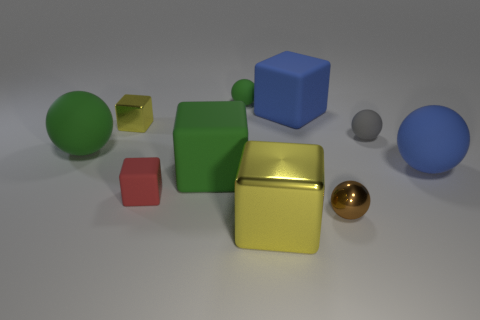How many yellow cubes have the same material as the small brown ball?
Your answer should be very brief. 2. The metallic object that is the same color as the large shiny block is what shape?
Your response must be concise. Cube. Do the small red matte thing on the left side of the brown ball and the small green object have the same shape?
Offer a very short reply. No. What is the color of the tiny cube that is the same material as the tiny green thing?
Your response must be concise. Red. There is a yellow metallic block that is behind the small sphere that is in front of the big blue matte sphere; is there a green matte sphere behind it?
Your answer should be very brief. Yes. What is the shape of the tiny brown metallic object?
Keep it short and to the point. Sphere. Are there fewer objects that are left of the gray object than big blue matte cylinders?
Provide a short and direct response. No. Are there any red rubber things of the same shape as the tiny green matte thing?
Offer a terse response. No. What is the shape of the brown metallic thing that is the same size as the gray sphere?
Your answer should be compact. Sphere. How many objects are green matte blocks or tiny green things?
Your response must be concise. 2. 